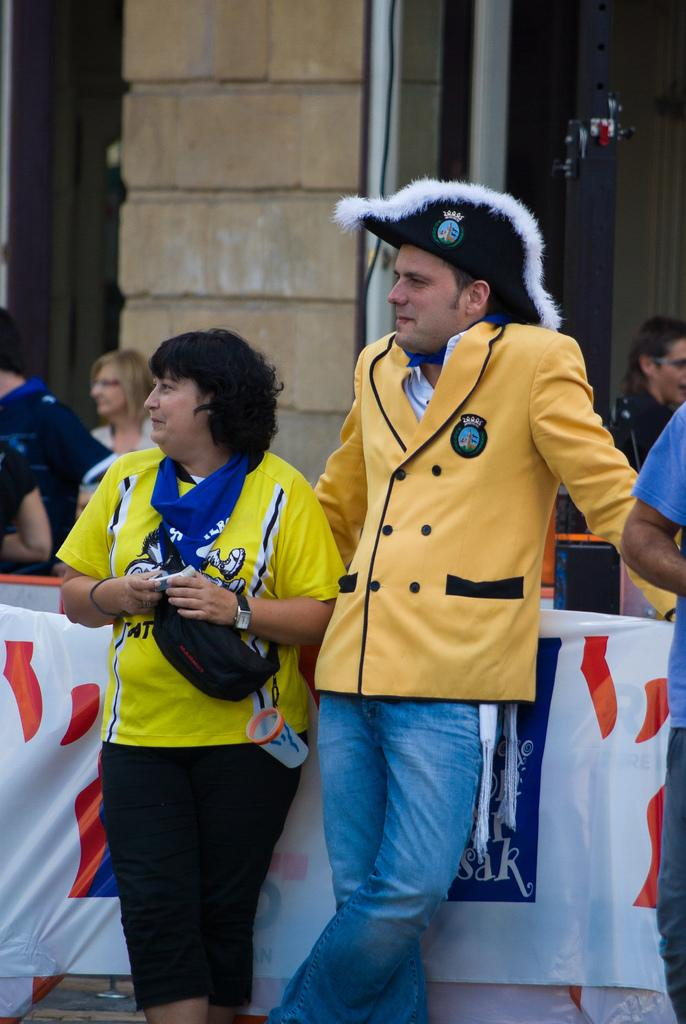What are the people in the middle of the image doing? The people in the middle of the image are standing and watching something. What can be seen behind the people in the middle? There is a banner behind the people in the middle. Are there any other people visible in the image? Yes, there are more people standing behind the banner. What is visible at the top of the image? There is a wall at the top of the image. What type of sponge is being used by the people in the image? There is no sponge visible in the image; the people are standing and watching something. What color is the shirt worn by the person in the front row? The provided facts do not mention any specific colors of clothing worn by the people in the image. 